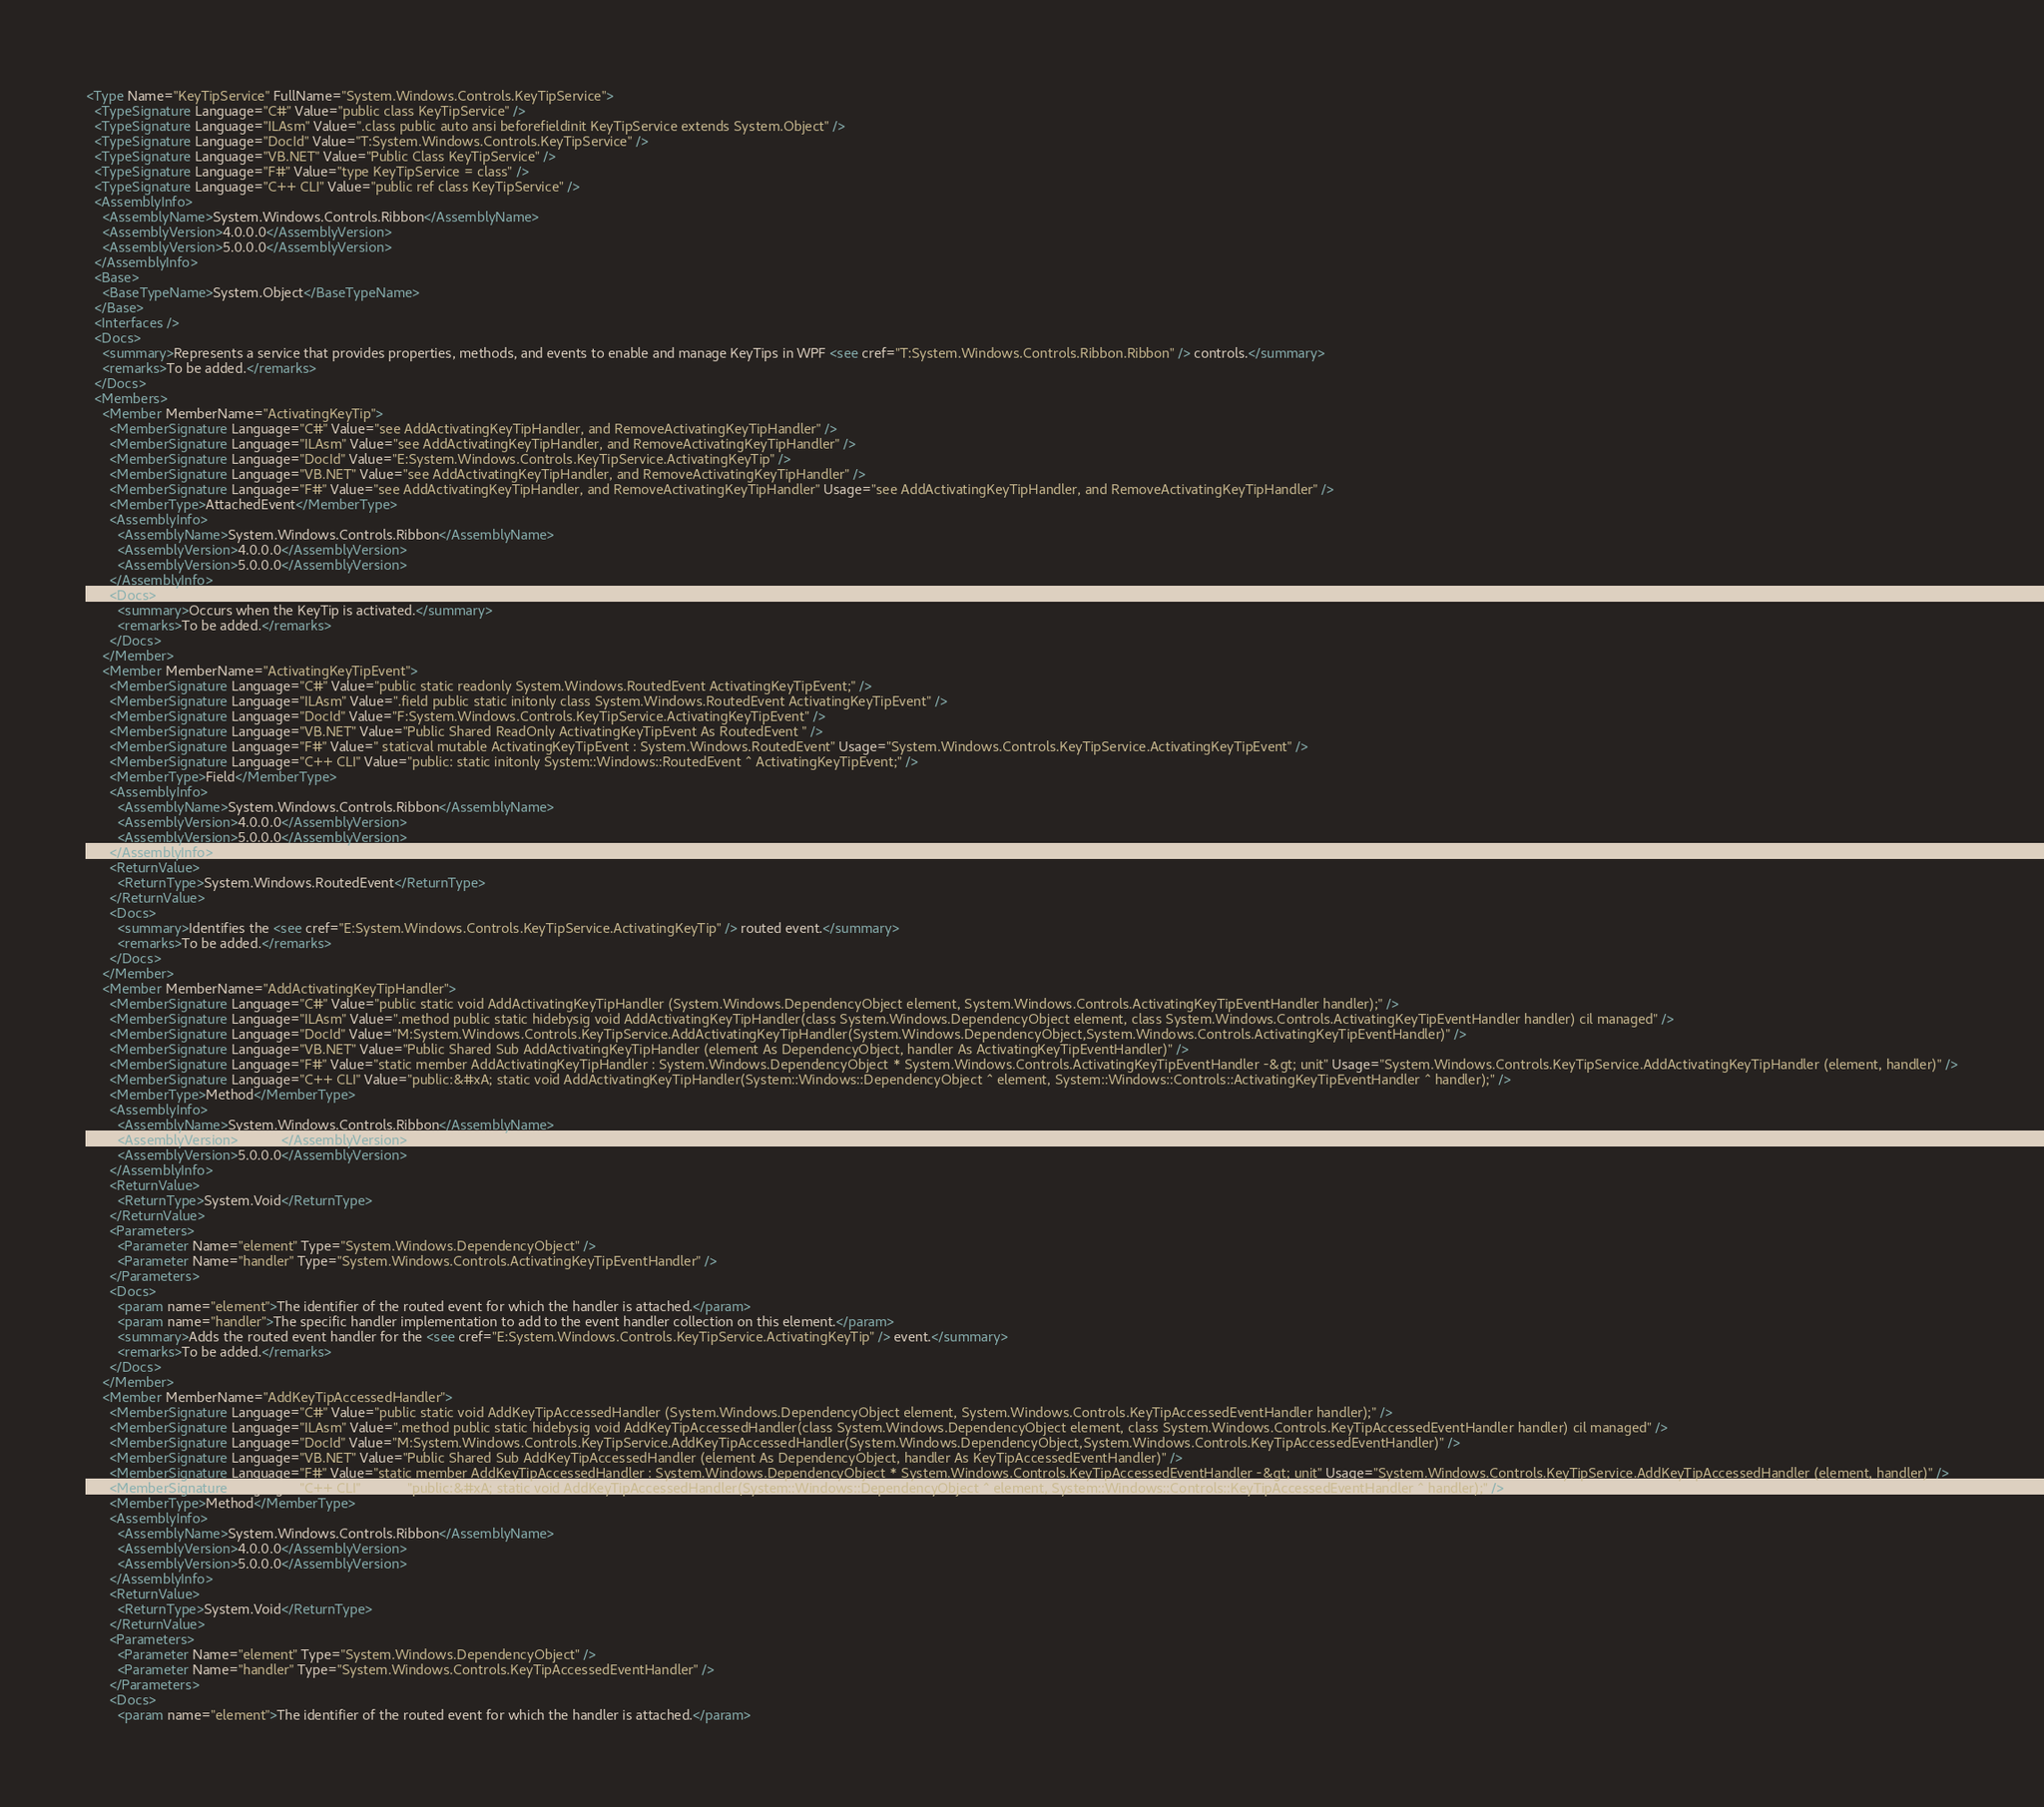Convert code to text. <code><loc_0><loc_0><loc_500><loc_500><_XML_><Type Name="KeyTipService" FullName="System.Windows.Controls.KeyTipService">
  <TypeSignature Language="C#" Value="public class KeyTipService" />
  <TypeSignature Language="ILAsm" Value=".class public auto ansi beforefieldinit KeyTipService extends System.Object" />
  <TypeSignature Language="DocId" Value="T:System.Windows.Controls.KeyTipService" />
  <TypeSignature Language="VB.NET" Value="Public Class KeyTipService" />
  <TypeSignature Language="F#" Value="type KeyTipService = class" />
  <TypeSignature Language="C++ CLI" Value="public ref class KeyTipService" />
  <AssemblyInfo>
    <AssemblyName>System.Windows.Controls.Ribbon</AssemblyName>
    <AssemblyVersion>4.0.0.0</AssemblyVersion>
    <AssemblyVersion>5.0.0.0</AssemblyVersion>
  </AssemblyInfo>
  <Base>
    <BaseTypeName>System.Object</BaseTypeName>
  </Base>
  <Interfaces />
  <Docs>
    <summary>Represents a service that provides properties, methods, and events to enable and manage KeyTips in WPF <see cref="T:System.Windows.Controls.Ribbon.Ribbon" /> controls.</summary>
    <remarks>To be added.</remarks>
  </Docs>
  <Members>
    <Member MemberName="ActivatingKeyTip">
      <MemberSignature Language="C#" Value="see AddActivatingKeyTipHandler, and RemoveActivatingKeyTipHandler" />
      <MemberSignature Language="ILAsm" Value="see AddActivatingKeyTipHandler, and RemoveActivatingKeyTipHandler" />
      <MemberSignature Language="DocId" Value="E:System.Windows.Controls.KeyTipService.ActivatingKeyTip" />
      <MemberSignature Language="VB.NET" Value="see AddActivatingKeyTipHandler, and RemoveActivatingKeyTipHandler" />
      <MemberSignature Language="F#" Value="see AddActivatingKeyTipHandler, and RemoveActivatingKeyTipHandler" Usage="see AddActivatingKeyTipHandler, and RemoveActivatingKeyTipHandler" />
      <MemberType>AttachedEvent</MemberType>
      <AssemblyInfo>
        <AssemblyName>System.Windows.Controls.Ribbon</AssemblyName>
        <AssemblyVersion>4.0.0.0</AssemblyVersion>
        <AssemblyVersion>5.0.0.0</AssemblyVersion>
      </AssemblyInfo>
      <Docs>
        <summary>Occurs when the KeyTip is activated.</summary>
        <remarks>To be added.</remarks>
      </Docs>
    </Member>
    <Member MemberName="ActivatingKeyTipEvent">
      <MemberSignature Language="C#" Value="public static readonly System.Windows.RoutedEvent ActivatingKeyTipEvent;" />
      <MemberSignature Language="ILAsm" Value=".field public static initonly class System.Windows.RoutedEvent ActivatingKeyTipEvent" />
      <MemberSignature Language="DocId" Value="F:System.Windows.Controls.KeyTipService.ActivatingKeyTipEvent" />
      <MemberSignature Language="VB.NET" Value="Public Shared ReadOnly ActivatingKeyTipEvent As RoutedEvent " />
      <MemberSignature Language="F#" Value=" staticval mutable ActivatingKeyTipEvent : System.Windows.RoutedEvent" Usage="System.Windows.Controls.KeyTipService.ActivatingKeyTipEvent" />
      <MemberSignature Language="C++ CLI" Value="public: static initonly System::Windows::RoutedEvent ^ ActivatingKeyTipEvent;" />
      <MemberType>Field</MemberType>
      <AssemblyInfo>
        <AssemblyName>System.Windows.Controls.Ribbon</AssemblyName>
        <AssemblyVersion>4.0.0.0</AssemblyVersion>
        <AssemblyVersion>5.0.0.0</AssemblyVersion>
      </AssemblyInfo>
      <ReturnValue>
        <ReturnType>System.Windows.RoutedEvent</ReturnType>
      </ReturnValue>
      <Docs>
        <summary>Identifies the <see cref="E:System.Windows.Controls.KeyTipService.ActivatingKeyTip" /> routed event.</summary>
        <remarks>To be added.</remarks>
      </Docs>
    </Member>
    <Member MemberName="AddActivatingKeyTipHandler">
      <MemberSignature Language="C#" Value="public static void AddActivatingKeyTipHandler (System.Windows.DependencyObject element, System.Windows.Controls.ActivatingKeyTipEventHandler handler);" />
      <MemberSignature Language="ILAsm" Value=".method public static hidebysig void AddActivatingKeyTipHandler(class System.Windows.DependencyObject element, class System.Windows.Controls.ActivatingKeyTipEventHandler handler) cil managed" />
      <MemberSignature Language="DocId" Value="M:System.Windows.Controls.KeyTipService.AddActivatingKeyTipHandler(System.Windows.DependencyObject,System.Windows.Controls.ActivatingKeyTipEventHandler)" />
      <MemberSignature Language="VB.NET" Value="Public Shared Sub AddActivatingKeyTipHandler (element As DependencyObject, handler As ActivatingKeyTipEventHandler)" />
      <MemberSignature Language="F#" Value="static member AddActivatingKeyTipHandler : System.Windows.DependencyObject * System.Windows.Controls.ActivatingKeyTipEventHandler -&gt; unit" Usage="System.Windows.Controls.KeyTipService.AddActivatingKeyTipHandler (element, handler)" />
      <MemberSignature Language="C++ CLI" Value="public:&#xA; static void AddActivatingKeyTipHandler(System::Windows::DependencyObject ^ element, System::Windows::Controls::ActivatingKeyTipEventHandler ^ handler);" />
      <MemberType>Method</MemberType>
      <AssemblyInfo>
        <AssemblyName>System.Windows.Controls.Ribbon</AssemblyName>
        <AssemblyVersion>4.0.0.0</AssemblyVersion>
        <AssemblyVersion>5.0.0.0</AssemblyVersion>
      </AssemblyInfo>
      <ReturnValue>
        <ReturnType>System.Void</ReturnType>
      </ReturnValue>
      <Parameters>
        <Parameter Name="element" Type="System.Windows.DependencyObject" />
        <Parameter Name="handler" Type="System.Windows.Controls.ActivatingKeyTipEventHandler" />
      </Parameters>
      <Docs>
        <param name="element">The identifier of the routed event for which the handler is attached.</param>
        <param name="handler">The specific handler implementation to add to the event handler collection on this element.</param>
        <summary>Adds the routed event handler for the <see cref="E:System.Windows.Controls.KeyTipService.ActivatingKeyTip" /> event.</summary>
        <remarks>To be added.</remarks>
      </Docs>
    </Member>
    <Member MemberName="AddKeyTipAccessedHandler">
      <MemberSignature Language="C#" Value="public static void AddKeyTipAccessedHandler (System.Windows.DependencyObject element, System.Windows.Controls.KeyTipAccessedEventHandler handler);" />
      <MemberSignature Language="ILAsm" Value=".method public static hidebysig void AddKeyTipAccessedHandler(class System.Windows.DependencyObject element, class System.Windows.Controls.KeyTipAccessedEventHandler handler) cil managed" />
      <MemberSignature Language="DocId" Value="M:System.Windows.Controls.KeyTipService.AddKeyTipAccessedHandler(System.Windows.DependencyObject,System.Windows.Controls.KeyTipAccessedEventHandler)" />
      <MemberSignature Language="VB.NET" Value="Public Shared Sub AddKeyTipAccessedHandler (element As DependencyObject, handler As KeyTipAccessedEventHandler)" />
      <MemberSignature Language="F#" Value="static member AddKeyTipAccessedHandler : System.Windows.DependencyObject * System.Windows.Controls.KeyTipAccessedEventHandler -&gt; unit" Usage="System.Windows.Controls.KeyTipService.AddKeyTipAccessedHandler (element, handler)" />
      <MemberSignature Language="C++ CLI" Value="public:&#xA; static void AddKeyTipAccessedHandler(System::Windows::DependencyObject ^ element, System::Windows::Controls::KeyTipAccessedEventHandler ^ handler);" />
      <MemberType>Method</MemberType>
      <AssemblyInfo>
        <AssemblyName>System.Windows.Controls.Ribbon</AssemblyName>
        <AssemblyVersion>4.0.0.0</AssemblyVersion>
        <AssemblyVersion>5.0.0.0</AssemblyVersion>
      </AssemblyInfo>
      <ReturnValue>
        <ReturnType>System.Void</ReturnType>
      </ReturnValue>
      <Parameters>
        <Parameter Name="element" Type="System.Windows.DependencyObject" />
        <Parameter Name="handler" Type="System.Windows.Controls.KeyTipAccessedEventHandler" />
      </Parameters>
      <Docs>
        <param name="element">The identifier of the routed event for which the handler is attached.</param></code> 